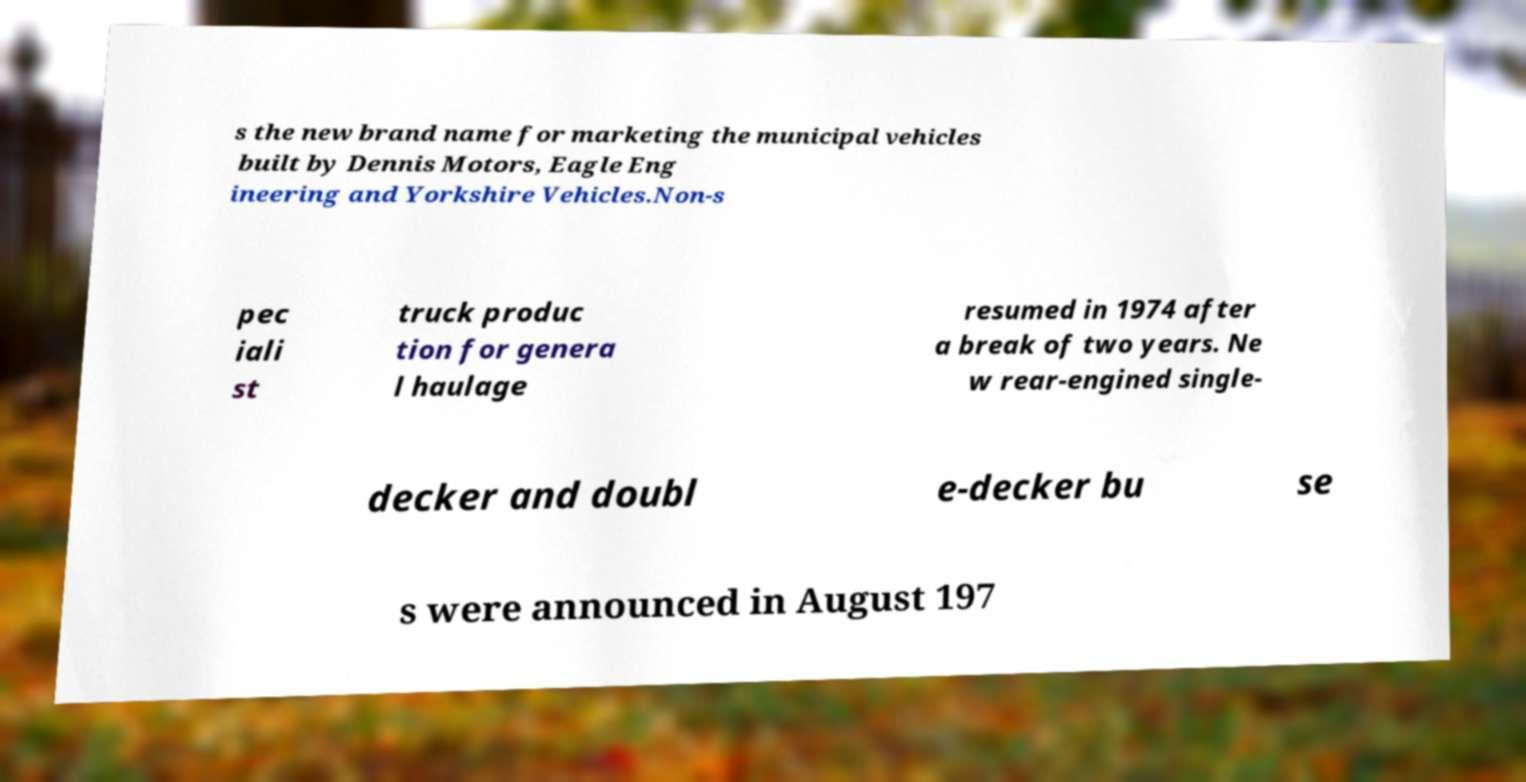Can you read and provide the text displayed in the image?This photo seems to have some interesting text. Can you extract and type it out for me? s the new brand name for marketing the municipal vehicles built by Dennis Motors, Eagle Eng ineering and Yorkshire Vehicles.Non-s pec iali st truck produc tion for genera l haulage resumed in 1974 after a break of two years. Ne w rear-engined single- decker and doubl e-decker bu se s were announced in August 197 